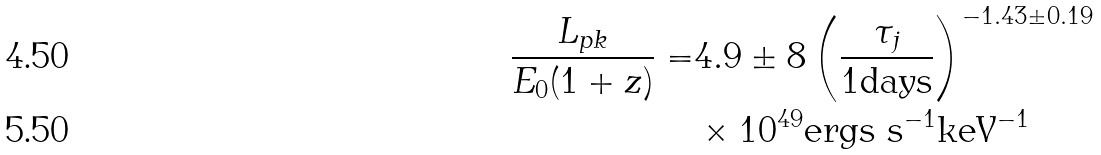<formula> <loc_0><loc_0><loc_500><loc_500>\frac { L _ { p k } } { E _ { 0 } ( 1 + z ) } = & 4 . 9 \pm 8 \left ( \frac { \tau _ { j } } { 1 \text {days} } \right ) ^ { - 1 . 4 3 \pm 0 . 1 9 } \\ & \times 1 0 ^ { 4 9 } \text {ergs s} ^ { - 1 } \text {keV} ^ { - 1 }</formula> 